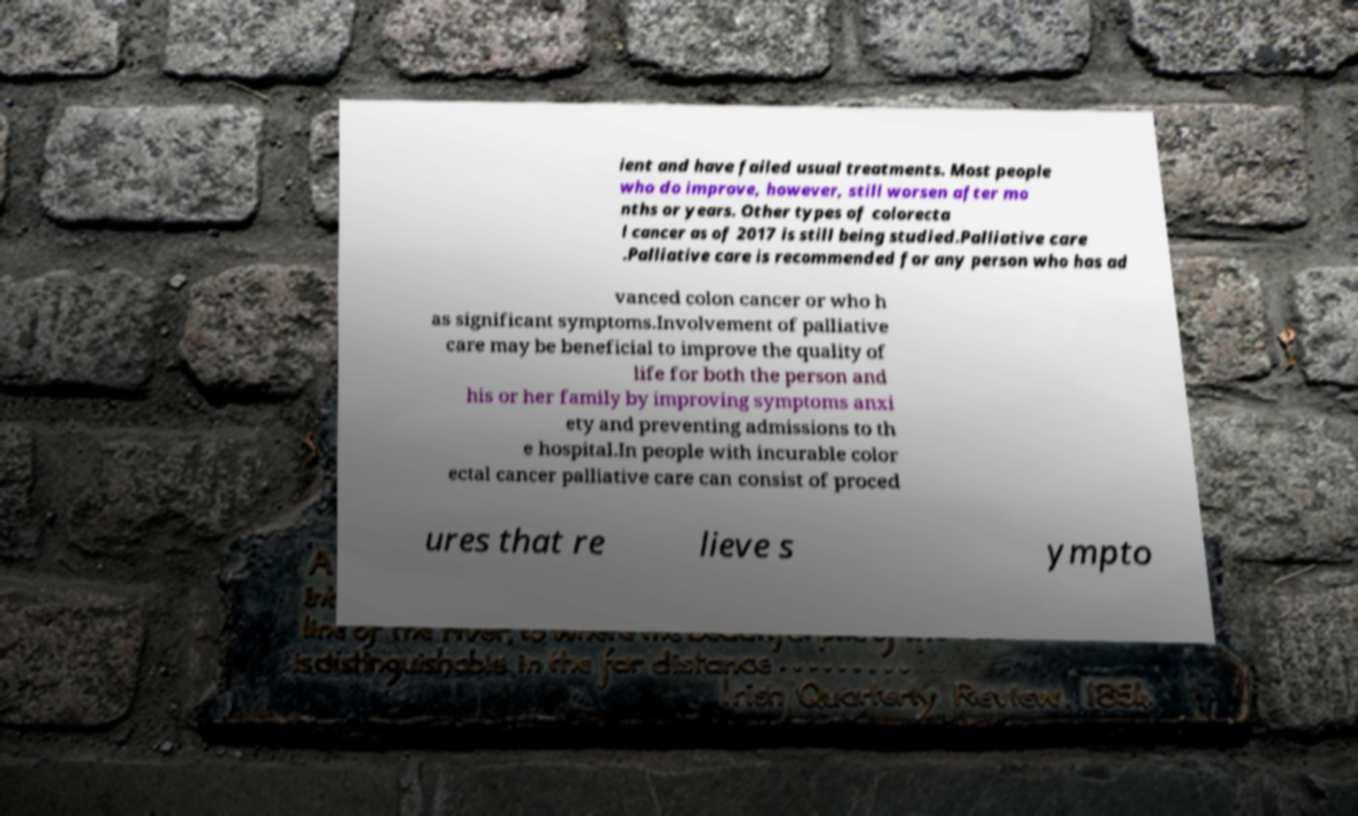I need the written content from this picture converted into text. Can you do that? ient and have failed usual treatments. Most people who do improve, however, still worsen after mo nths or years. Other types of colorecta l cancer as of 2017 is still being studied.Palliative care .Palliative care is recommended for any person who has ad vanced colon cancer or who h as significant symptoms.Involvement of palliative care may be beneficial to improve the quality of life for both the person and his or her family by improving symptoms anxi ety and preventing admissions to th e hospital.In people with incurable color ectal cancer palliative care can consist of proced ures that re lieve s ympto 